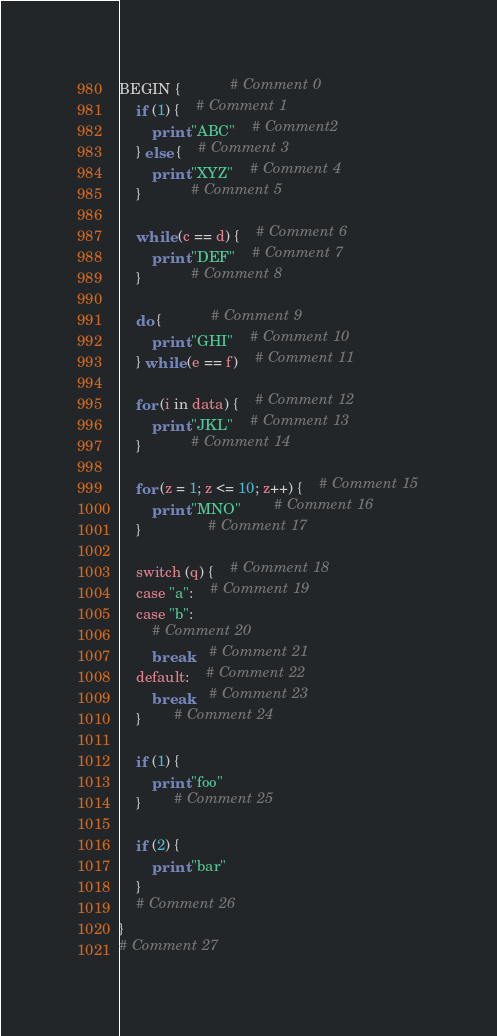<code> <loc_0><loc_0><loc_500><loc_500><_Awk_>BEGIN {			# Comment 0
	if (1) {	# Comment 1
		print "ABC"	# Comment2
	} else {	# Comment 3
		print "XYZ"	# Comment 4
	}			# Comment 5

	while (c == d) {	# Comment 6
		print "DEF"	# Comment 7
	}			# Comment 8

	do {			# Comment 9
		print "GHI"	# Comment 10
	} while (e == f)	# Comment 11

	for (i in data) {	# Comment 12
		print "JKL"	# Comment 13
	}			# Comment 14

	for (z = 1; z <= 10; z++) {	# Comment 15
		print "MNO"		# Comment 16
	}				# Comment 17

	switch (q) {	# Comment 18
	case "a":	# Comment 19
	case "b":
		# Comment 20
		break	# Comment 21
	default:	# Comment 22
		break	# Comment 23
	}		# Comment 24

	if (1) {
		print "foo"
	}		# Comment 25

	if (2) {
		print "bar"
	}
	# Comment 26
}
# Comment 27
</code> 